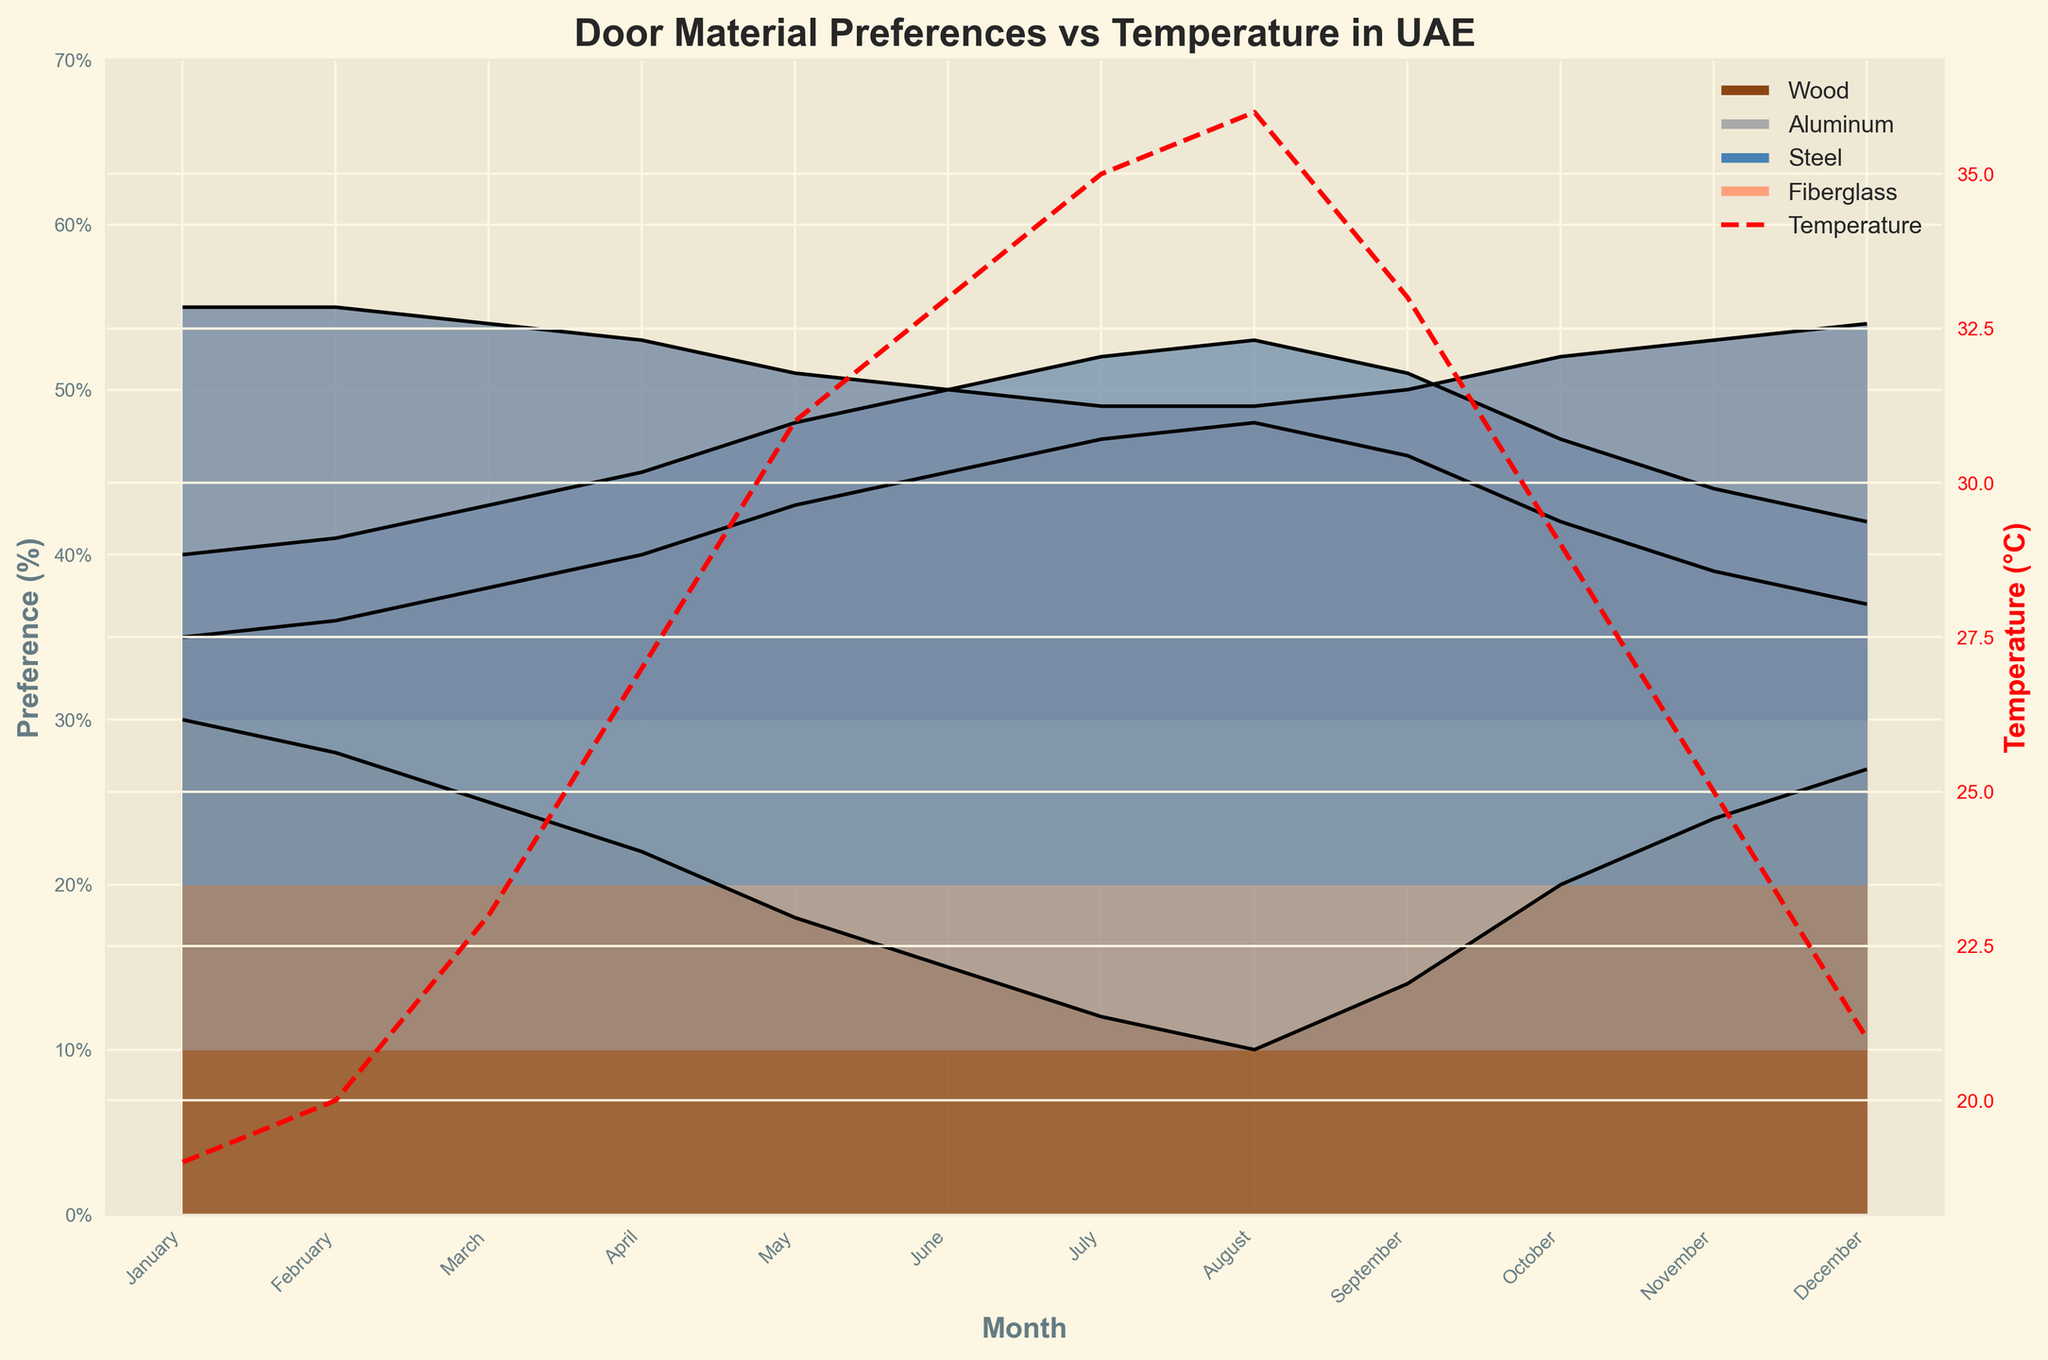What's the title of the plot? The title of the plot is prominently displayed at the top. It reads, "Door Material Preferences vs Temperature in UAE".
Answer: Door Material Preferences vs Temperature in UAE Which month shows the highest temperature? By looking at the red dashed line on the secondary y-axis (indicating temperature in °C), August shows the highest temperature.
Answer: August What material has the highest preference in January? In January, the ridgeline for "Wood" extends highest on the primary y-axis, indicating it has the highest preference.
Answer: Wood In which month does Steel have its highest preference? By observing the height of the Steel ridgeline across different months, Steel reaches its highest preference in August.
Answer: August How does the preference for Aluminum change from January to July? By tracking the height of the Aluminum ridgeline from January to July, it shows a decline from 25% in January to around 12% in July.
Answer: It decreases What is the approximate difference in preference for Fiberglass between February and June? Fiberglass has a preference of about 25% in February and 20% in June. The difference is roughly 5%.
Answer: 5% Which material shows the least variation in preference throughout the year? By observing the consistency in ridgeline heights across months, Fiberglass appears to show the least variation.
Answer: Fiberglass Compare the preference trends of Wood and Aluminum over the year. Wood shows a decreasing trend from January (highest) to August (lowest) and then it increases towards December. Aluminum slightly decreases from January to February but remains relatively stable from March to December.
Answer: Wood decreases then increases; Aluminum remains relatively stable During the hottest month, which material is least preferred? In August, the month with the highest temperature, the ridgeline for Wood is the lowest, indicating it is the least preferred material.
Answer: Wood Is there any correlation between the monthly temperature and the preference for Steel? By comparing the trend of the ridgeline for Steel and the temperature line, both increase from January to August and then decrease, showing a positive correlation.
Answer: Yes 